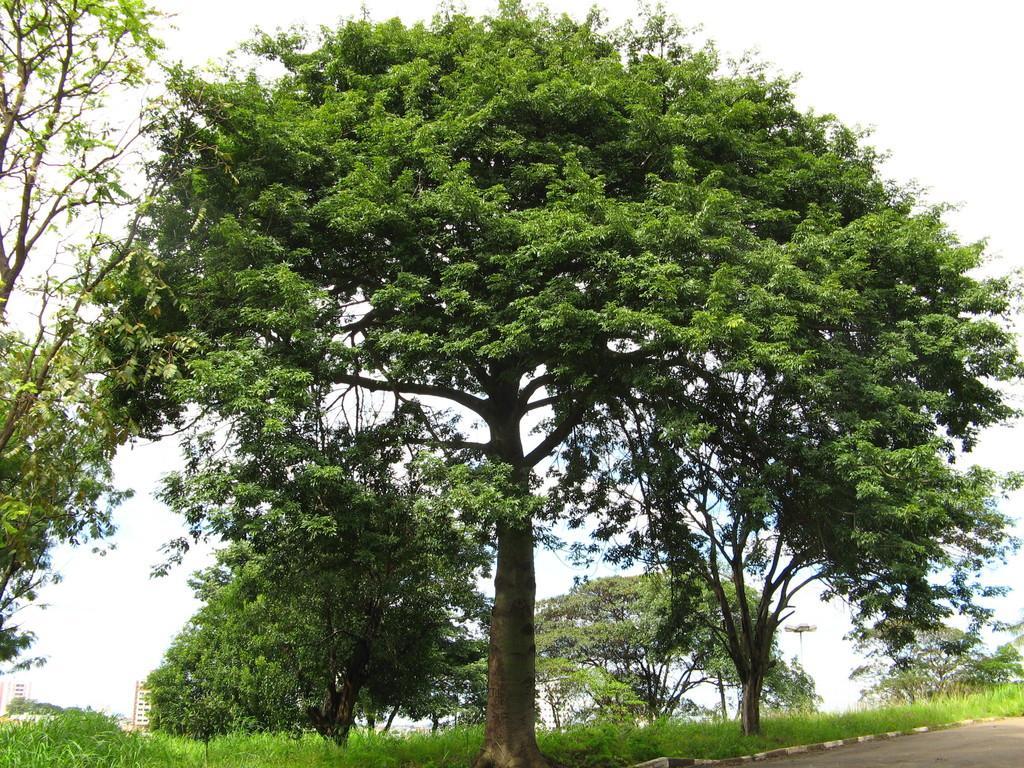Can you describe this image briefly? In this image there are trees. There is grass on the ground. In the bottom right there is a road. In the background there are buildings. At the top there is the sky. 